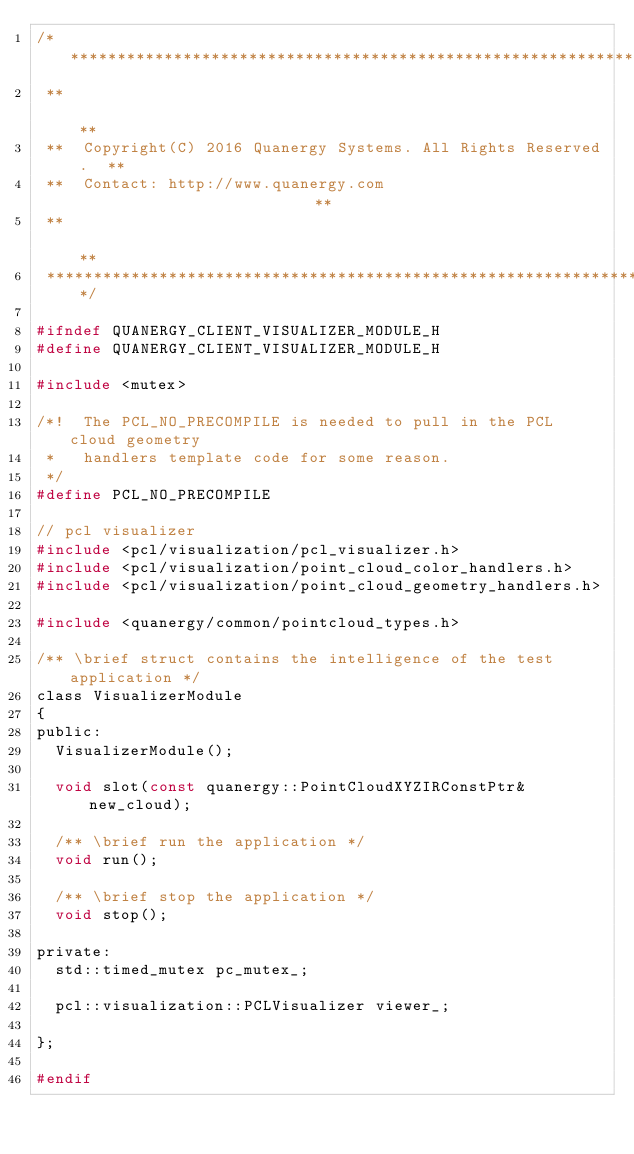Convert code to text. <code><loc_0><loc_0><loc_500><loc_500><_C_>/****************************************************************
 **                                                            **
 **  Copyright(C) 2016 Quanergy Systems. All Rights Reserved.  **
 **  Contact: http://www.quanergy.com                          **
 **                                                            **
 ****************************************************************/

#ifndef QUANERGY_CLIENT_VISUALIZER_MODULE_H
#define QUANERGY_CLIENT_VISUALIZER_MODULE_H

#include <mutex>

/*!  The PCL_NO_PRECOMPILE is needed to pull in the PCL cloud geometry
 *   handlers template code for some reason.
 */
#define PCL_NO_PRECOMPILE

// pcl visualizer
#include <pcl/visualization/pcl_visualizer.h>
#include <pcl/visualization/point_cloud_color_handlers.h>
#include <pcl/visualization/point_cloud_geometry_handlers.h>

#include <quanergy/common/pointcloud_types.h>

/** \brief struct contains the intelligence of the test application */
class VisualizerModule
{
public:
  VisualizerModule();

  void slot(const quanergy::PointCloudXYZIRConstPtr& new_cloud);

  /** \brief run the application */
  void run();

  /** \brief stop the application */
  void stop();

private:
  std::timed_mutex pc_mutex_;

  pcl::visualization::PCLVisualizer viewer_;

};

#endif
</code> 